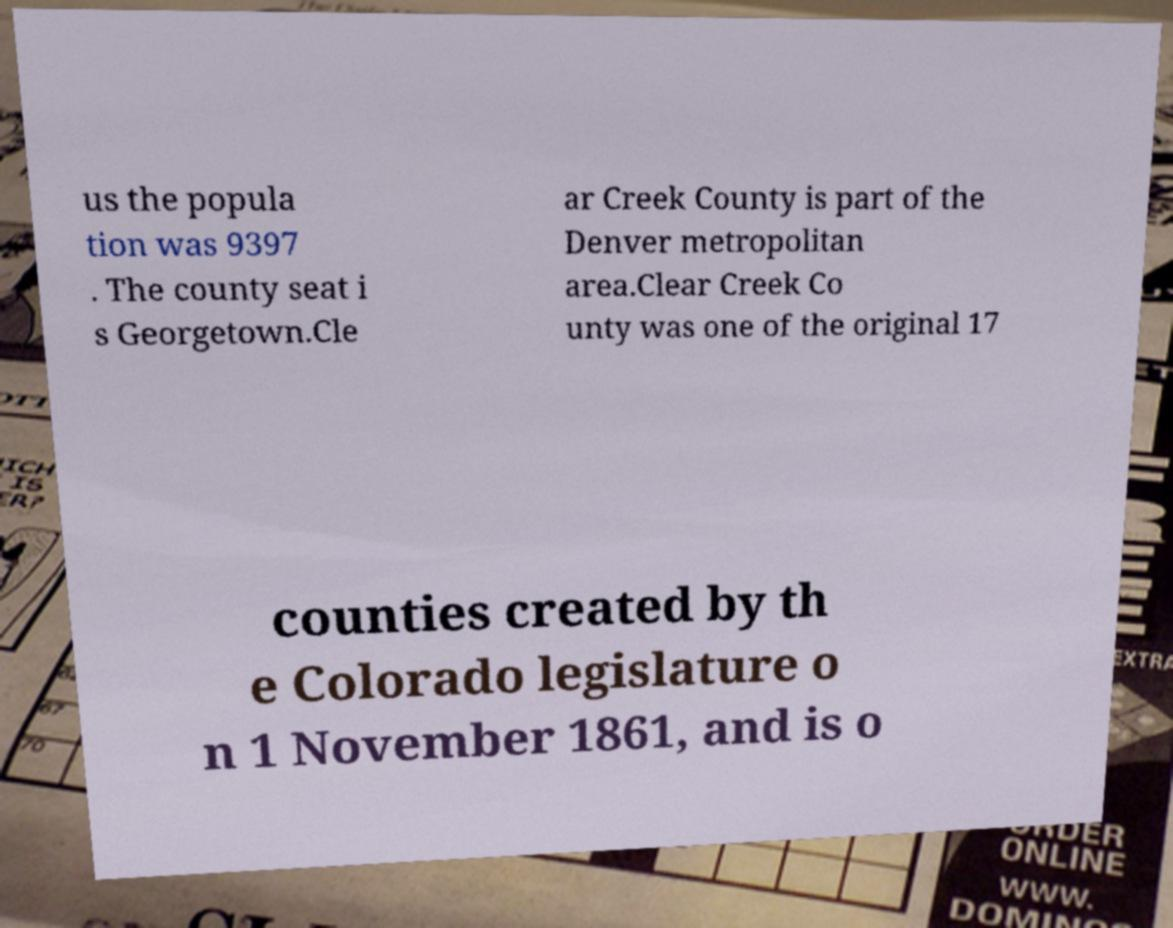There's text embedded in this image that I need extracted. Can you transcribe it verbatim? us the popula tion was 9397 . The county seat i s Georgetown.Cle ar Creek County is part of the Denver metropolitan area.Clear Creek Co unty was one of the original 17 counties created by th e Colorado legislature o n 1 November 1861, and is o 